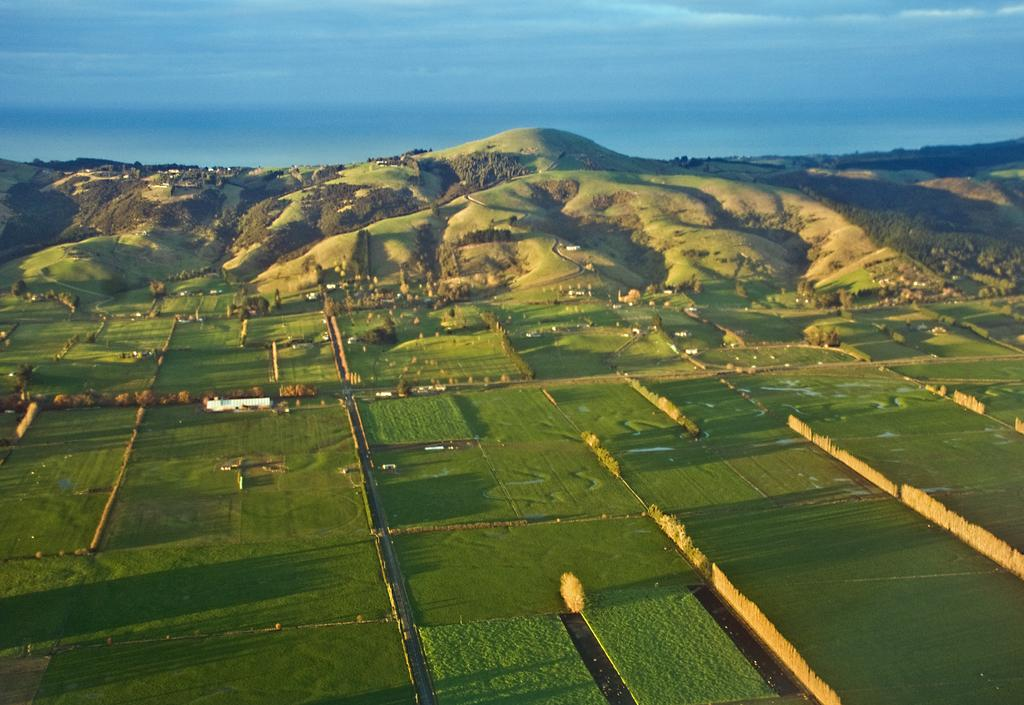What type of vegetation is present on the ground in the image? There is grass on the ground in the image. What other natural elements can be seen in the image? There are trees and mountains in the image. What is the condition of the sky in the image? The sky is cloudy in the image. Can you provide any advice from the donkey in the image? There is no donkey present in the image, so no advice can be provided from it. What type of operation is being performed on the mountain in the image? There is no operation being performed on the mountain in the image; it is a natural formation. 